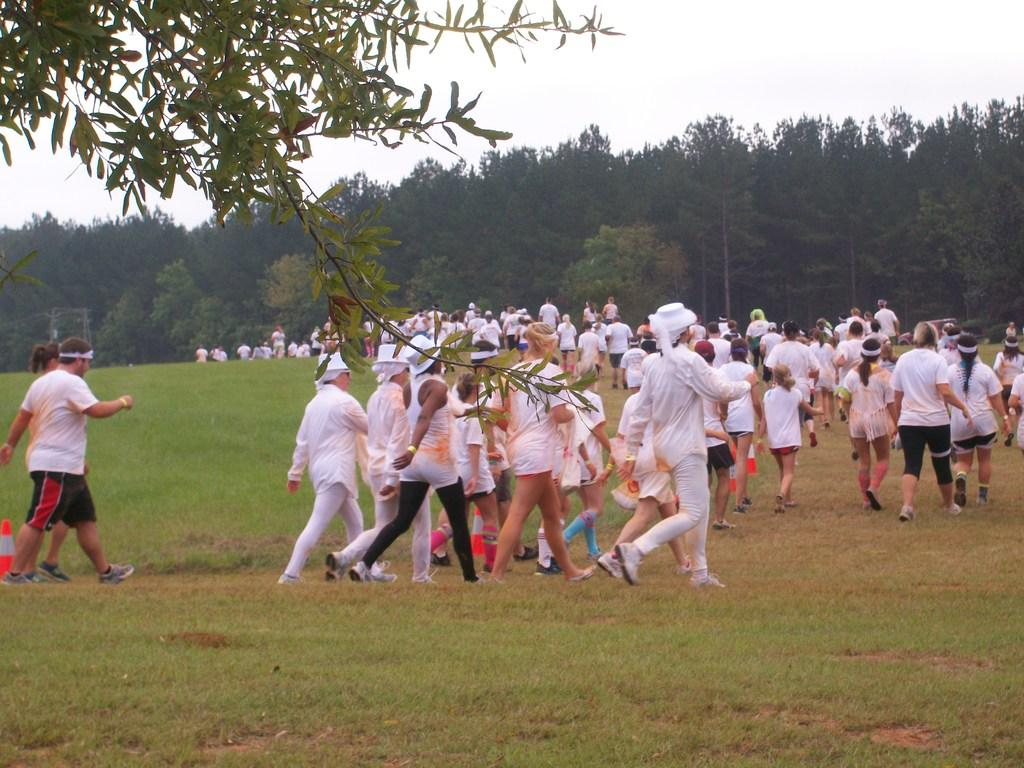Who or what can be seen in the image? There are people in the image. What are the people doing in the image? The people are walking on the grassland. What can be seen in the distance in the image? There are trees in the background of the image. What type of substance is being sprayed by the governor in the image? There is no governor or substance being sprayed in the image; it features people walking on grassland with trees in the background. 